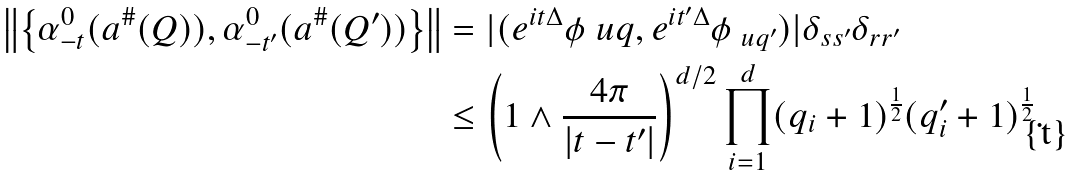Convert formula to latex. <formula><loc_0><loc_0><loc_500><loc_500>\left \| \left \{ \alpha _ { - t } ^ { 0 } ( a ^ { \# } ( Q ) ) , \alpha _ { - t ^ { \prime } } ^ { 0 } ( a ^ { \# } ( Q ^ { \prime } ) ) \right \} \right \| & = | ( e ^ { i t \Delta } \phi _ { \ } u q , e ^ { i t ^ { \prime } \Delta } \phi _ { \ u q ^ { \prime } } ) | \delta _ { s s ^ { \prime } } \delta _ { r r ^ { \prime } } \\ & \leq \left ( 1 \wedge \frac { 4 \pi } { | t - t ^ { \prime } | } \right ) ^ { d / 2 } \prod _ { i = 1 } ^ { d } ( q _ { i } + 1 ) ^ { \frac { 1 } { 2 } } ( q _ { i } ^ { \prime } + 1 ) ^ { \frac { 1 } { 2 } } .</formula> 